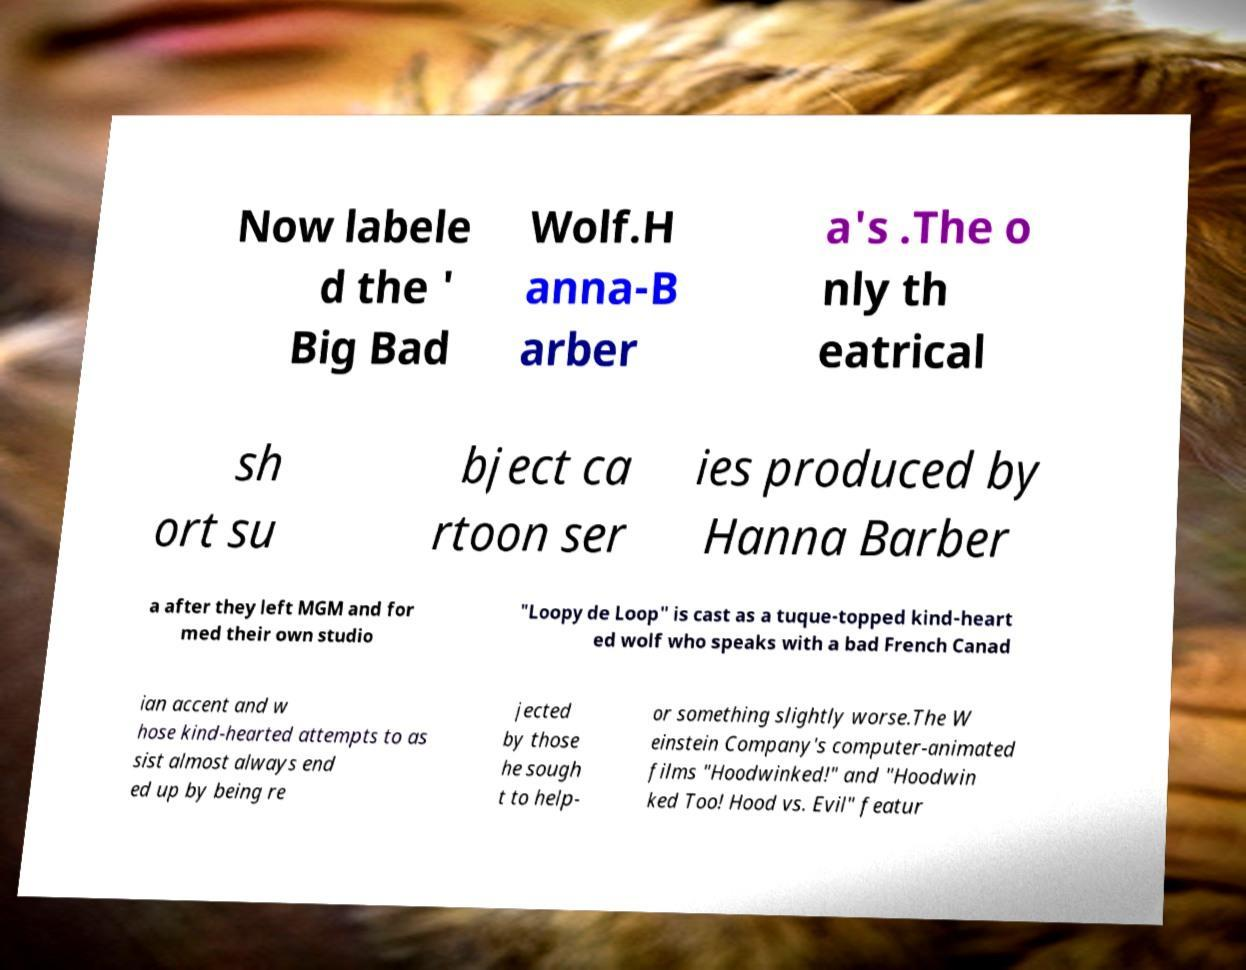I need the written content from this picture converted into text. Can you do that? Now labele d the ' Big Bad Wolf.H anna-B arber a's .The o nly th eatrical sh ort su bject ca rtoon ser ies produced by Hanna Barber a after they left MGM and for med their own studio "Loopy de Loop" is cast as a tuque-topped kind-heart ed wolf who speaks with a bad French Canad ian accent and w hose kind-hearted attempts to as sist almost always end ed up by being re jected by those he sough t to help- or something slightly worse.The W einstein Company's computer-animated films "Hoodwinked!" and "Hoodwin ked Too! Hood vs. Evil" featur 